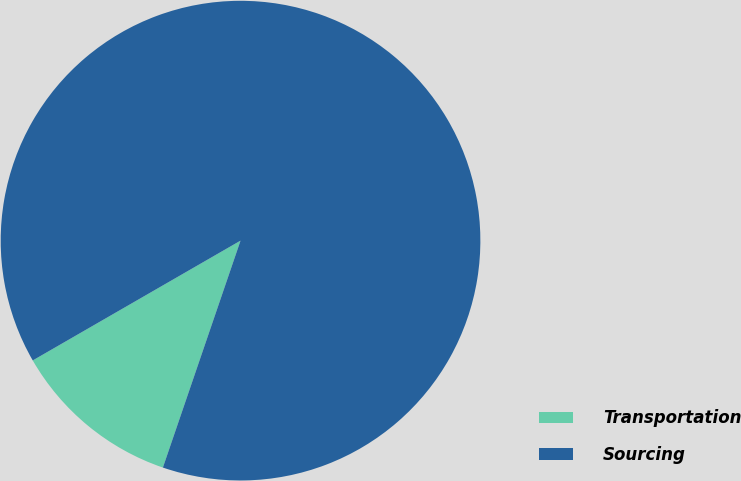Convert chart to OTSL. <chart><loc_0><loc_0><loc_500><loc_500><pie_chart><fcel>Transportation<fcel>Sourcing<nl><fcel>11.43%<fcel>88.57%<nl></chart> 